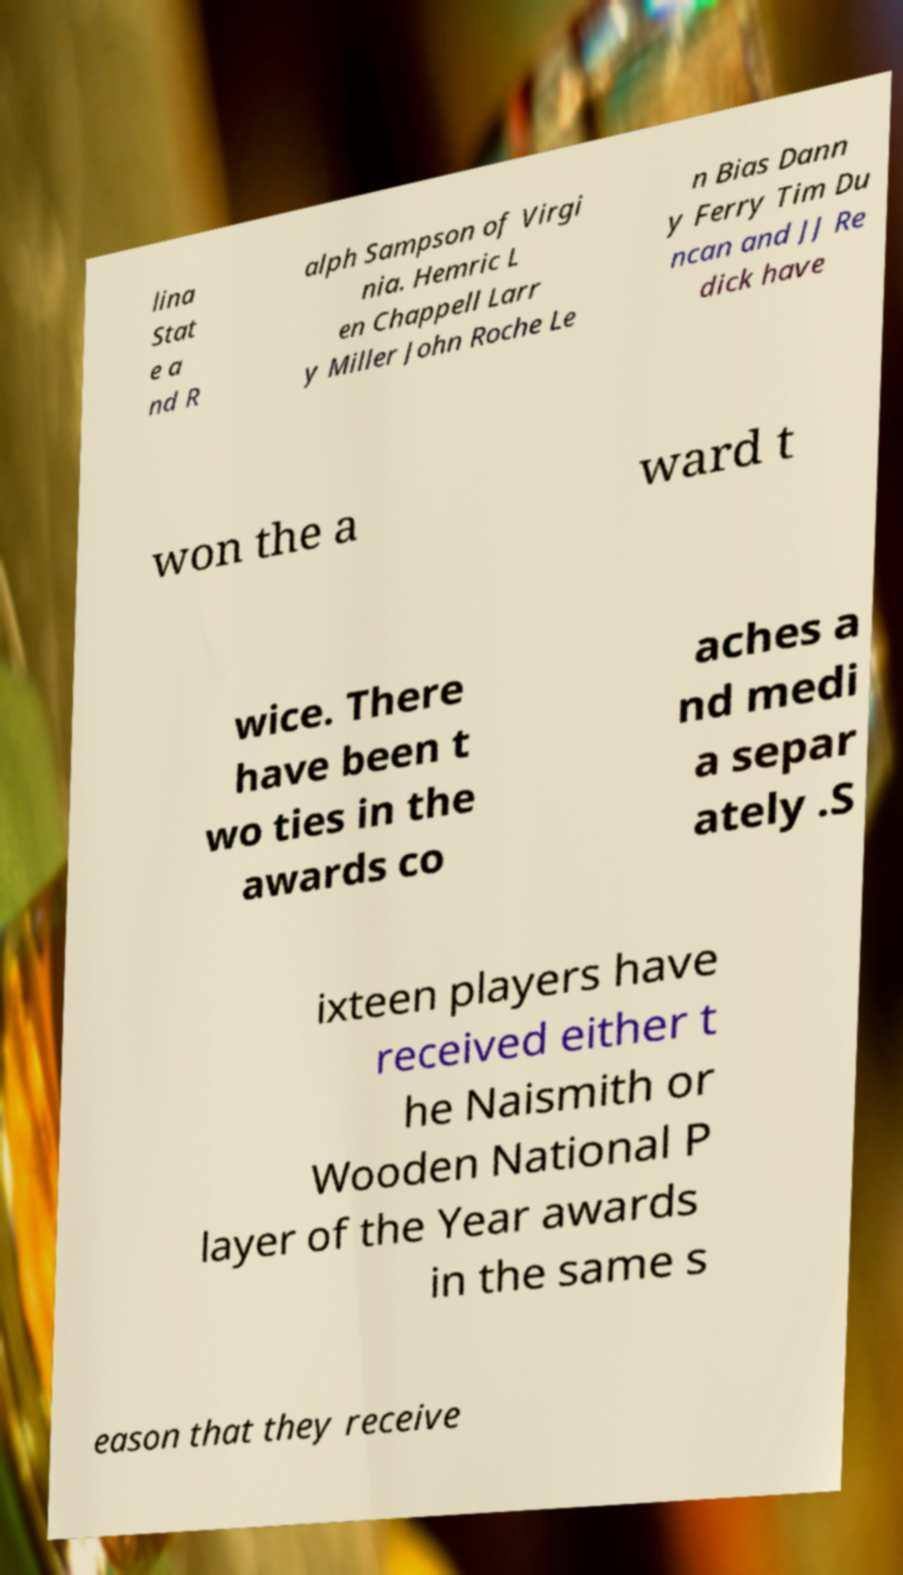For documentation purposes, I need the text within this image transcribed. Could you provide that? lina Stat e a nd R alph Sampson of Virgi nia. Hemric L en Chappell Larr y Miller John Roche Le n Bias Dann y Ferry Tim Du ncan and JJ Re dick have won the a ward t wice. There have been t wo ties in the awards co aches a nd medi a separ ately .S ixteen players have received either t he Naismith or Wooden National P layer of the Year awards in the same s eason that they receive 